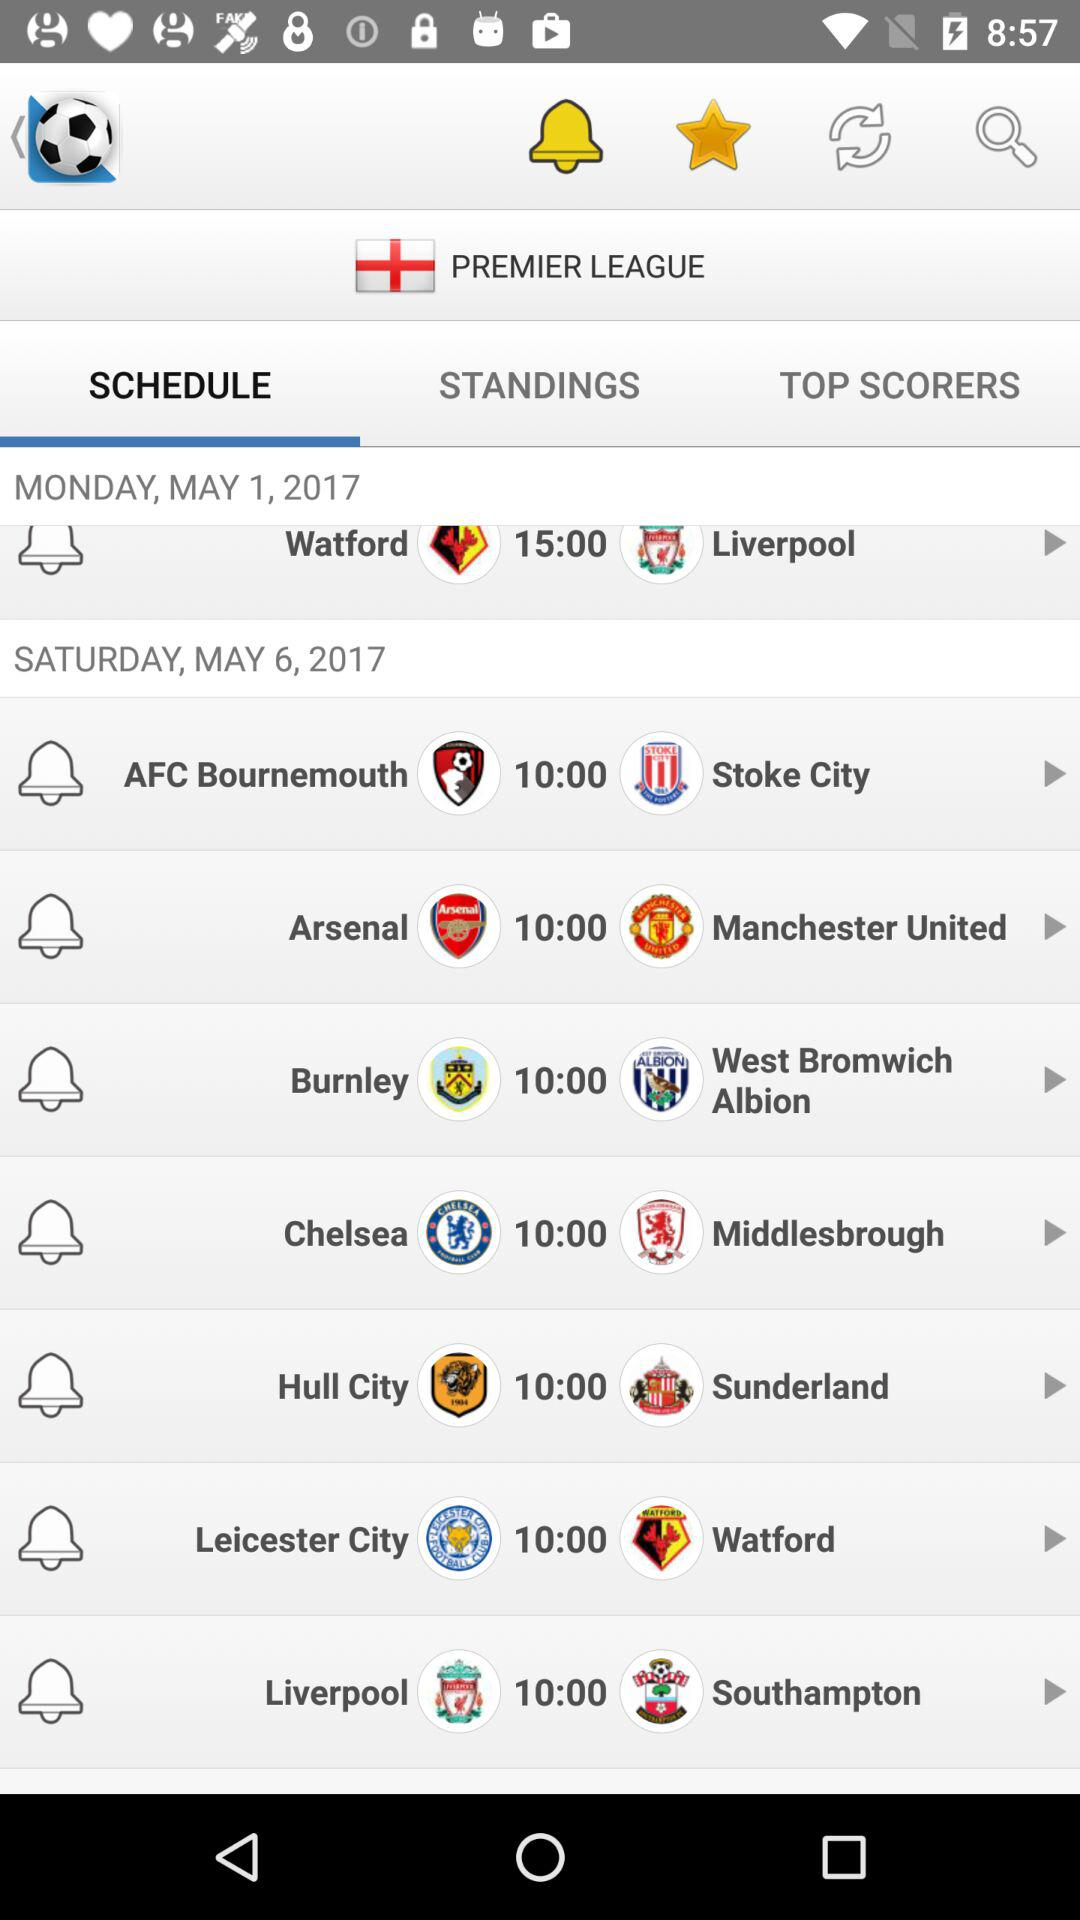On Saturday, May 17, 2017, which premier league is scheduled?
When the provided information is insufficient, respond with <no answer>. <no answer> 